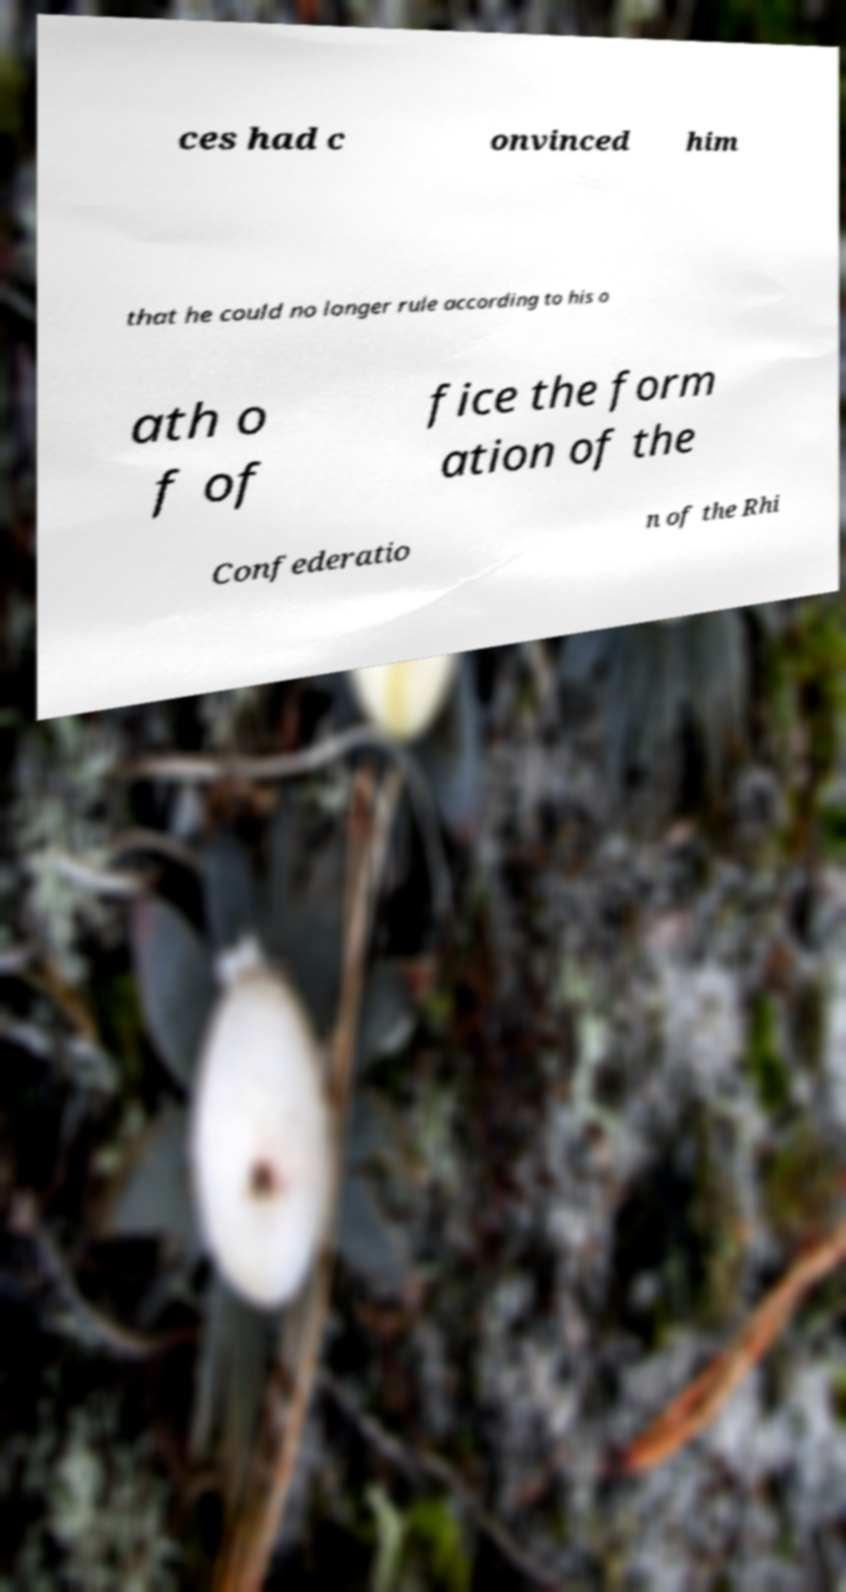Could you assist in decoding the text presented in this image and type it out clearly? ces had c onvinced him that he could no longer rule according to his o ath o f of fice the form ation of the Confederatio n of the Rhi 